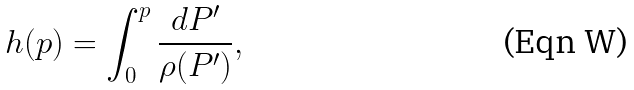Convert formula to latex. <formula><loc_0><loc_0><loc_500><loc_500>h ( p ) = \int _ { 0 } ^ { p } \frac { d P ^ { \prime } } { \rho ( P ^ { \prime } ) } ,</formula> 